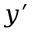Convert formula to latex. <formula><loc_0><loc_0><loc_500><loc_500>y ^ { \prime }</formula> 